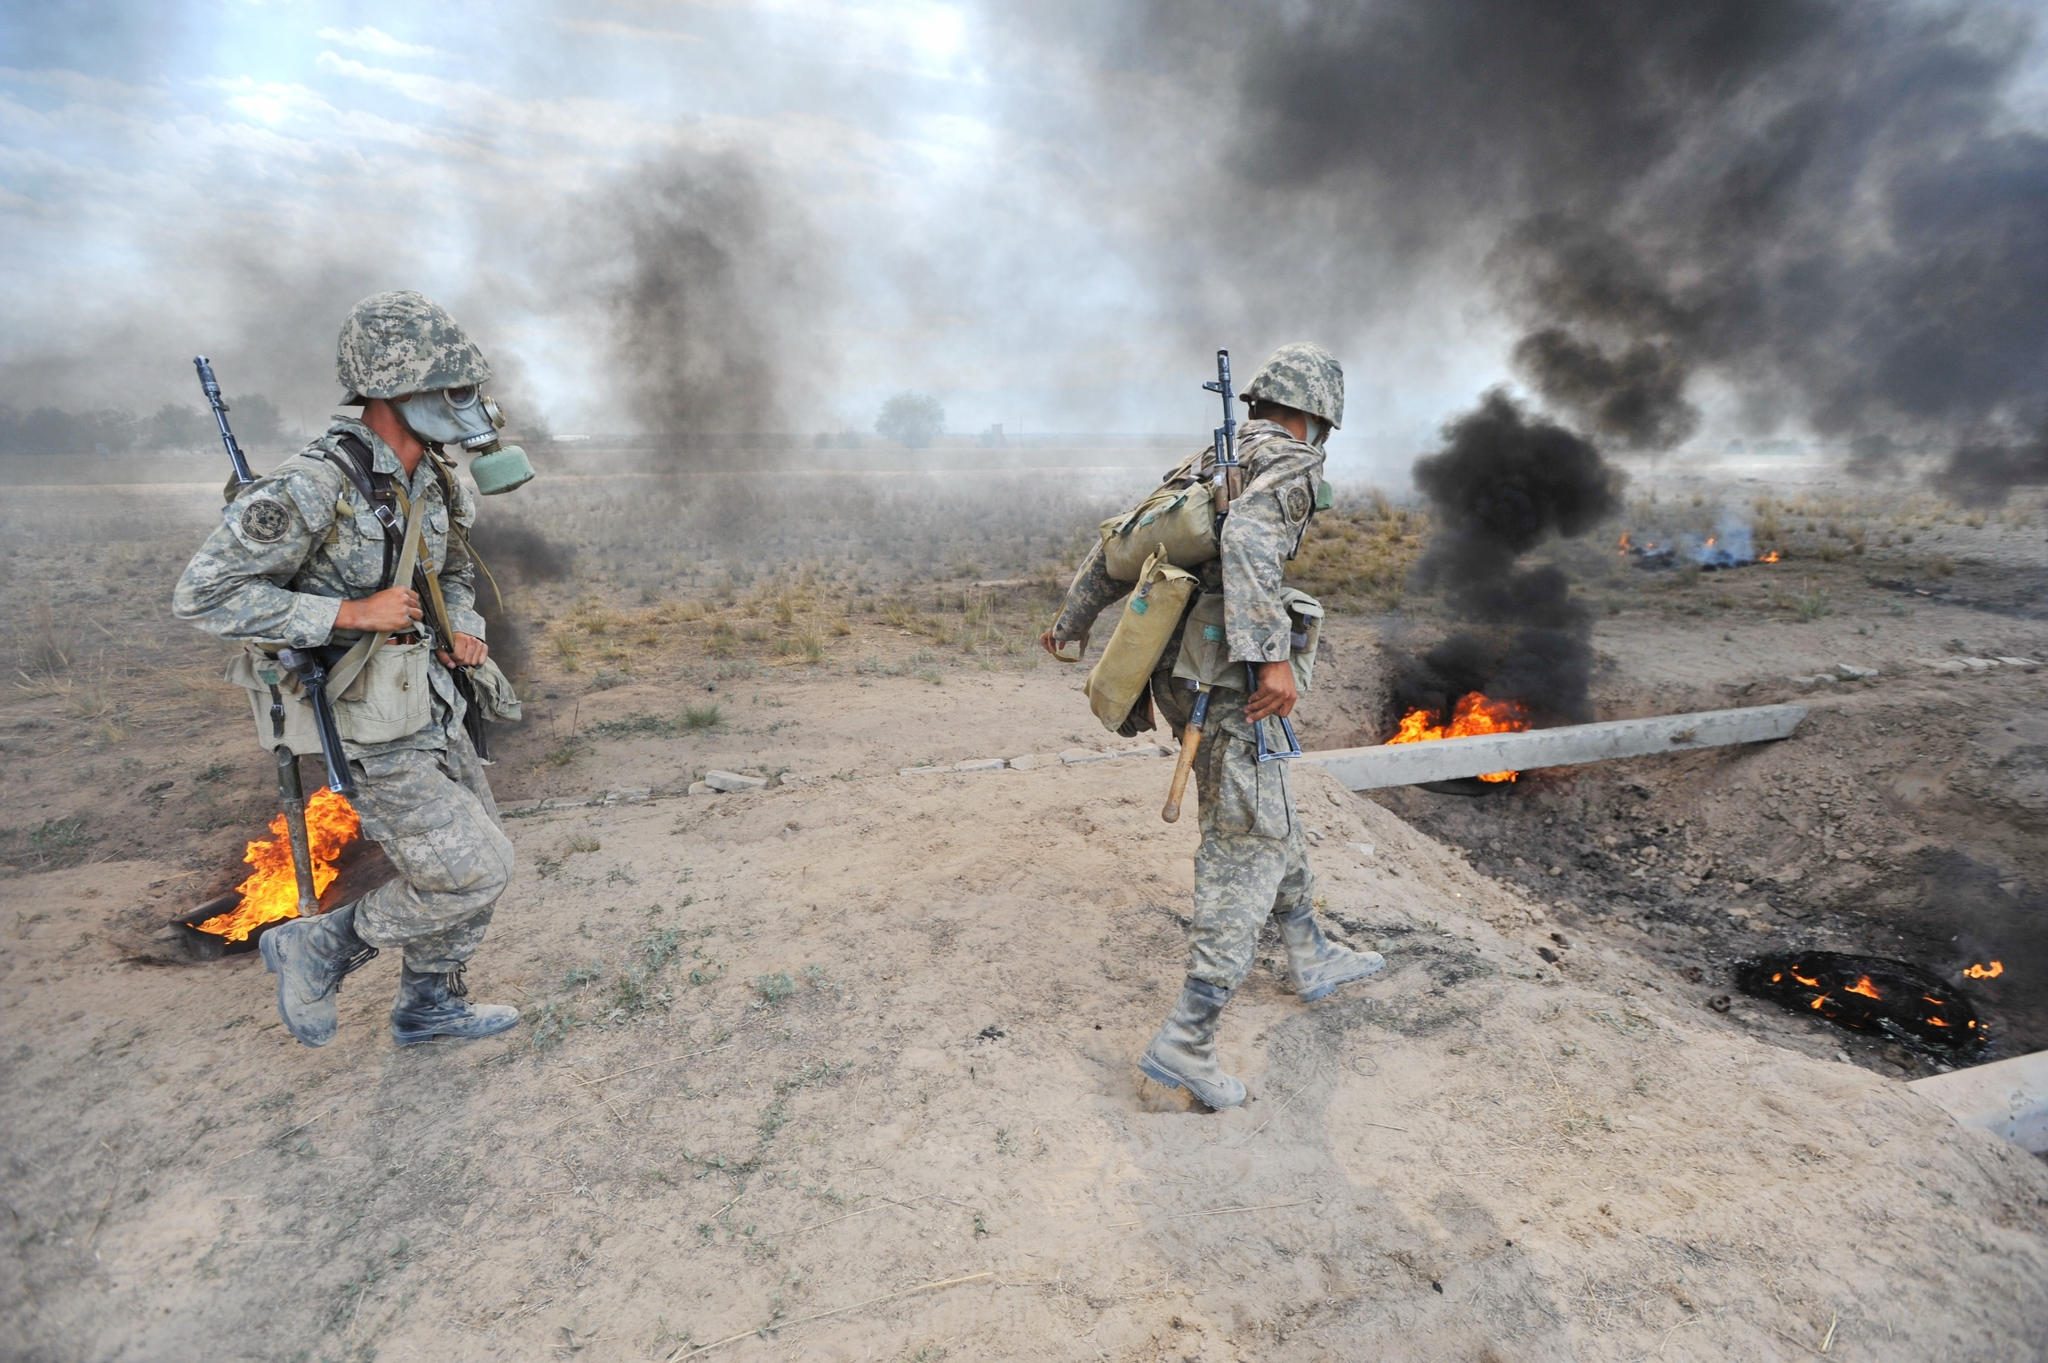Imagine the soldiers are exploring an alien planet. How would their equipment adapt to this new environment? On an alien planet, soldiers' equipment would be highly specialized to adapt to unknown and potentially hazardous conditions. Their combat uniforms might be made of advanced materials capable of withstanding extreme temperatures, radiation, and corrosive atmospheres. Their helmets could be equipped with an integrated life support system, offering breathable air, and heads-up displays showing environmental data and navigation cues. Weapons might be modular and adaptable to different energy sources found on the planet. Additionally, they'd carry multi-purpose tools for survival and interaction with alien ecosystems, such as advanced scanners, portable shelters, and repair kits for their gear. Autonomous drones or robotic companions could assist with reconnaissance, mapping, and even offer medical assistance in case of injury. Describe a possible interaction between the soldiers and native life forms they might discover. As the soldiers traverse the alien terrain, they could encounter native life forms, potentially intelligent or simple organisms. If the life forms are intelligent, initial interactions might involve cautious observation and non-threatening gestures to establish communication. Soldiers might use universal symbols, holographic projections, or language translation devices to convey peaceful intentions. The life forms' response would dictate the next steps, whether mutual understanding is achieved or if they need to retreat for safety. For simpler organisms, soldiers would avoid disturbing the local flora and fauna while documenting their behaviors and characteristics, providing valuable data for scientific analysis. Imagine these soldiers are actually part of a time-traveling expedition. How does the historical epoch they have traveled to influence their mission? If the soldiers are part of a time-traveling expedition, their mission could be influenced by the need to adapt to the technological, cultural, and environmental context of the historical epoch they find themselves in. For instance, if they traveled to an ancient civilization, their advanced weaponry and gear might draw significant attention, necessitating a cover story or disguise to blend in. The soldiers would have to adhere to strict protocols to avoid altering historical events, focusing on observation and non-interference. Their equipment might include non-lethal tools, historical reference materials, and devices to record and safely store data. They'd require knowledge of local languages, customs, and terrain to navigate efficiently and accomplish their mission without affecting the course of history. In this alternative reality, the soldiers use a blend of past and future technologies to maintain balance. For example, they might ride horses while employing holographic maps, or use tactical bows with advanced targeting systems. These juxtaposed methods help them blend in with the time period while retaining their strategic advantage. They must always be vigilant of the ripple effects their presence could create, ensuring they leave no trace behind. 